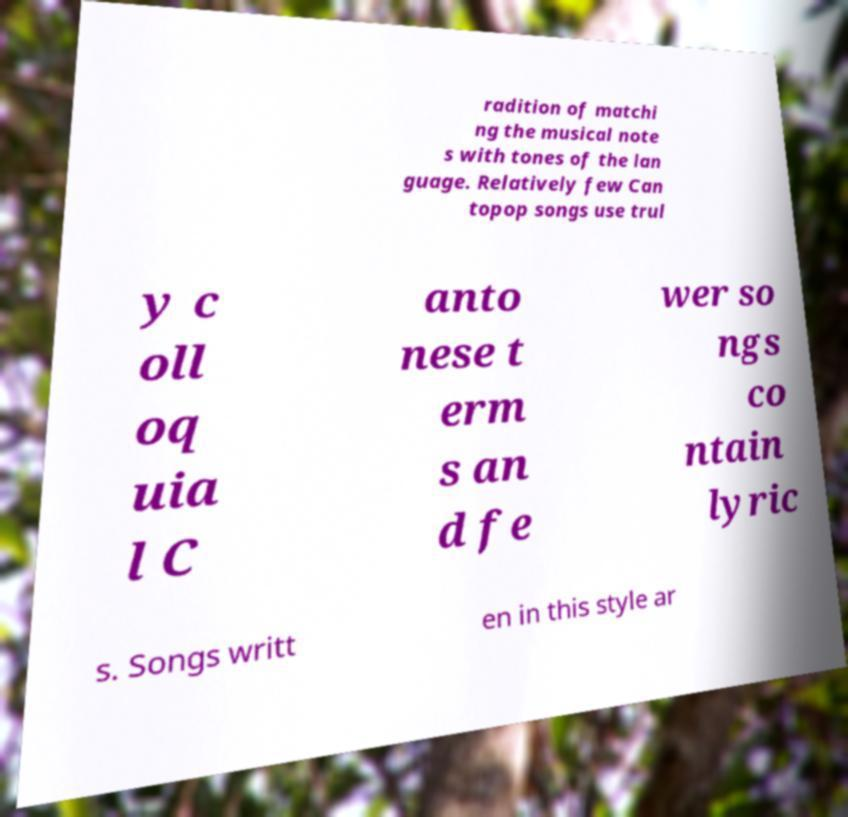Could you extract and type out the text from this image? radition of matchi ng the musical note s with tones of the lan guage. Relatively few Can topop songs use trul y c oll oq uia l C anto nese t erm s an d fe wer so ngs co ntain lyric s. Songs writt en in this style ar 